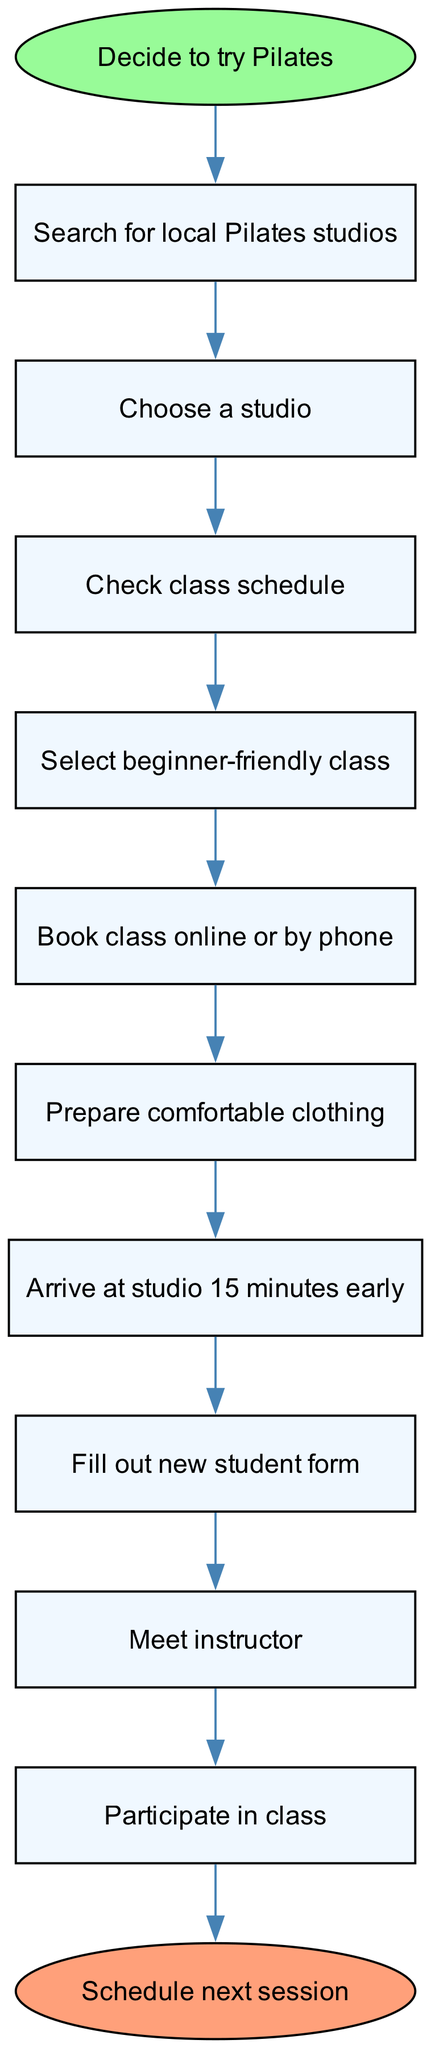What is the starting point of the process? The starting point is indicated by the oval node labeled "Decide to try Pilates". Therefore, the process begins at this point.
Answer: Decide to try Pilates How many steps are involved in booking and attending a Pilates class? To find the number of steps, we can count the actions listed before reaching the end node. There are a total of 10 steps leading to the end point.
Answer: 10 What action comes after "Check class schedule"? Following the "Check class schedule" step, the next action is to "Select beginner-friendly class" as indicated by the connection in the flow.
Answer: Select beginner-friendly class What is the last action before attending the class? The last action before participating in the class is "Meet instructor", which is the step before participating in the actual class.
Answer: Meet instructor If you want to prepare for the class, what should you do after booking it? After booking the class, you should "Prepare comfortable clothing", which is the subsequent action in the flow.
Answer: Prepare comfortable clothing What is the endpoint of the process? The endpoint of the process is shown as the oval node "Schedule next session", which concludes the series of actions.
Answer: Schedule next session Which action directly follows "Fill out new student form"? The next action after "Fill out new student form" is "Meet instructor", as illustrated in the flow where these two actions are connected sequentially.
Answer: Meet instructor What is the first action to take in this process? The first step to initiate the process is "Search for local Pilates studios", as indicated by the first action after the starting point.
Answer: Search for local Pilates studios What two actions are linked directly before "Participate in class"? The two actions that precede "Participate in class" are "Meet instructor" and "Fill out new student form". Both actions are necessary before participating.
Answer: Meet instructor and Fill out new student form 